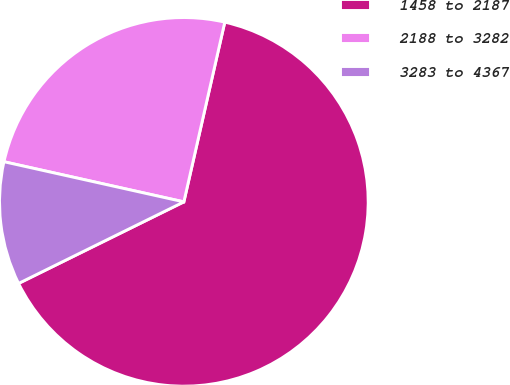Convert chart. <chart><loc_0><loc_0><loc_500><loc_500><pie_chart><fcel>1458 to 2187<fcel>2188 to 3282<fcel>3283 to 4367<nl><fcel>64.14%<fcel>25.07%<fcel>10.79%<nl></chart> 